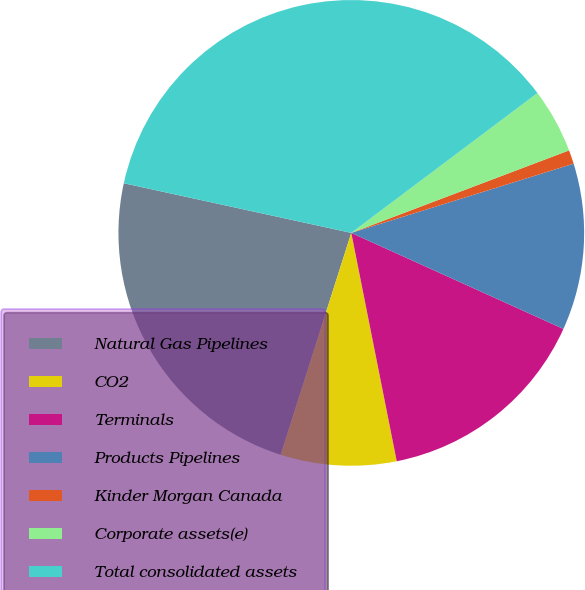<chart> <loc_0><loc_0><loc_500><loc_500><pie_chart><fcel>Natural Gas Pipelines<fcel>CO2<fcel>Terminals<fcel>Products Pipelines<fcel>Kinder Morgan Canada<fcel>Corporate assets(e)<fcel>Total consolidated assets<nl><fcel>23.52%<fcel>8.03%<fcel>15.11%<fcel>11.57%<fcel>0.96%<fcel>4.49%<fcel>36.33%<nl></chart> 